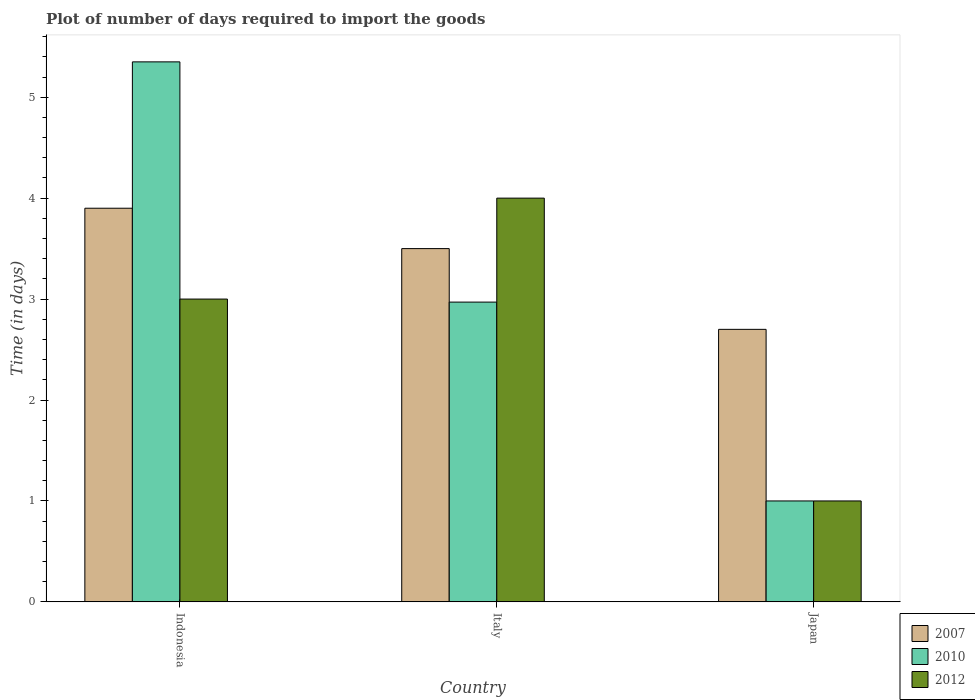How many groups of bars are there?
Keep it short and to the point. 3. Are the number of bars per tick equal to the number of legend labels?
Offer a very short reply. Yes. In how many cases, is the number of bars for a given country not equal to the number of legend labels?
Offer a very short reply. 0. What is the time required to import goods in 2012 in Italy?
Provide a short and direct response. 4. Across all countries, what is the maximum time required to import goods in 2010?
Offer a terse response. 5.35. What is the total time required to import goods in 2007 in the graph?
Ensure brevity in your answer.  10.1. What is the difference between the time required to import goods in 2007 in Italy and that in Japan?
Your answer should be compact. 0.8. What is the difference between the time required to import goods in 2012 in Indonesia and the time required to import goods in 2007 in Japan?
Make the answer very short. 0.3. What is the average time required to import goods in 2012 per country?
Your answer should be very brief. 2.67. What is the difference between the time required to import goods of/in 2012 and time required to import goods of/in 2010 in Indonesia?
Make the answer very short. -2.35. What is the ratio of the time required to import goods in 2012 in Italy to that in Japan?
Give a very brief answer. 4. What is the difference between the highest and the second highest time required to import goods in 2010?
Keep it short and to the point. -1.97. What is the difference between the highest and the lowest time required to import goods in 2012?
Keep it short and to the point. 3. In how many countries, is the time required to import goods in 2012 greater than the average time required to import goods in 2012 taken over all countries?
Offer a very short reply. 2. Is the sum of the time required to import goods in 2007 in Indonesia and Italy greater than the maximum time required to import goods in 2012 across all countries?
Your answer should be very brief. Yes. What does the 3rd bar from the left in Indonesia represents?
Make the answer very short. 2012. Is it the case that in every country, the sum of the time required to import goods in 2007 and time required to import goods in 2010 is greater than the time required to import goods in 2012?
Your response must be concise. Yes. Are all the bars in the graph horizontal?
Your answer should be compact. No. Are the values on the major ticks of Y-axis written in scientific E-notation?
Make the answer very short. No. Does the graph contain any zero values?
Provide a short and direct response. No. Does the graph contain grids?
Provide a succinct answer. No. Where does the legend appear in the graph?
Provide a short and direct response. Bottom right. What is the title of the graph?
Keep it short and to the point. Plot of number of days required to import the goods. What is the label or title of the Y-axis?
Make the answer very short. Time (in days). What is the Time (in days) in 2007 in Indonesia?
Offer a terse response. 3.9. What is the Time (in days) of 2010 in Indonesia?
Keep it short and to the point. 5.35. What is the Time (in days) in 2010 in Italy?
Keep it short and to the point. 2.97. What is the Time (in days) of 2012 in Japan?
Provide a short and direct response. 1. Across all countries, what is the maximum Time (in days) in 2007?
Provide a succinct answer. 3.9. Across all countries, what is the maximum Time (in days) of 2010?
Make the answer very short. 5.35. Across all countries, what is the minimum Time (in days) in 2010?
Your answer should be compact. 1. Across all countries, what is the minimum Time (in days) of 2012?
Offer a terse response. 1. What is the total Time (in days) in 2007 in the graph?
Offer a terse response. 10.1. What is the total Time (in days) of 2010 in the graph?
Make the answer very short. 9.32. What is the difference between the Time (in days) in 2007 in Indonesia and that in Italy?
Provide a short and direct response. 0.4. What is the difference between the Time (in days) of 2010 in Indonesia and that in Italy?
Your response must be concise. 2.38. What is the difference between the Time (in days) of 2012 in Indonesia and that in Italy?
Your response must be concise. -1. What is the difference between the Time (in days) in 2010 in Indonesia and that in Japan?
Provide a succinct answer. 4.35. What is the difference between the Time (in days) of 2012 in Indonesia and that in Japan?
Keep it short and to the point. 2. What is the difference between the Time (in days) of 2010 in Italy and that in Japan?
Your answer should be very brief. 1.97. What is the difference between the Time (in days) in 2010 in Indonesia and the Time (in days) in 2012 in Italy?
Offer a very short reply. 1.35. What is the difference between the Time (in days) of 2010 in Indonesia and the Time (in days) of 2012 in Japan?
Keep it short and to the point. 4.35. What is the difference between the Time (in days) in 2007 in Italy and the Time (in days) in 2010 in Japan?
Make the answer very short. 2.5. What is the difference between the Time (in days) of 2007 in Italy and the Time (in days) of 2012 in Japan?
Provide a succinct answer. 2.5. What is the difference between the Time (in days) of 2010 in Italy and the Time (in days) of 2012 in Japan?
Keep it short and to the point. 1.97. What is the average Time (in days) of 2007 per country?
Your answer should be compact. 3.37. What is the average Time (in days) in 2010 per country?
Your response must be concise. 3.11. What is the average Time (in days) of 2012 per country?
Offer a terse response. 2.67. What is the difference between the Time (in days) in 2007 and Time (in days) in 2010 in Indonesia?
Give a very brief answer. -1.45. What is the difference between the Time (in days) of 2010 and Time (in days) of 2012 in Indonesia?
Your answer should be compact. 2.35. What is the difference between the Time (in days) in 2007 and Time (in days) in 2010 in Italy?
Ensure brevity in your answer.  0.53. What is the difference between the Time (in days) of 2010 and Time (in days) of 2012 in Italy?
Ensure brevity in your answer.  -1.03. What is the difference between the Time (in days) of 2007 and Time (in days) of 2010 in Japan?
Provide a succinct answer. 1.7. What is the difference between the Time (in days) in 2010 and Time (in days) in 2012 in Japan?
Keep it short and to the point. 0. What is the ratio of the Time (in days) of 2007 in Indonesia to that in Italy?
Your answer should be very brief. 1.11. What is the ratio of the Time (in days) of 2010 in Indonesia to that in Italy?
Provide a short and direct response. 1.8. What is the ratio of the Time (in days) in 2007 in Indonesia to that in Japan?
Make the answer very short. 1.44. What is the ratio of the Time (in days) of 2010 in Indonesia to that in Japan?
Your response must be concise. 5.35. What is the ratio of the Time (in days) of 2012 in Indonesia to that in Japan?
Keep it short and to the point. 3. What is the ratio of the Time (in days) in 2007 in Italy to that in Japan?
Offer a terse response. 1.3. What is the ratio of the Time (in days) of 2010 in Italy to that in Japan?
Provide a succinct answer. 2.97. What is the ratio of the Time (in days) of 2012 in Italy to that in Japan?
Make the answer very short. 4. What is the difference between the highest and the second highest Time (in days) of 2007?
Provide a succinct answer. 0.4. What is the difference between the highest and the second highest Time (in days) of 2010?
Keep it short and to the point. 2.38. What is the difference between the highest and the lowest Time (in days) of 2010?
Your answer should be compact. 4.35. What is the difference between the highest and the lowest Time (in days) of 2012?
Offer a terse response. 3. 